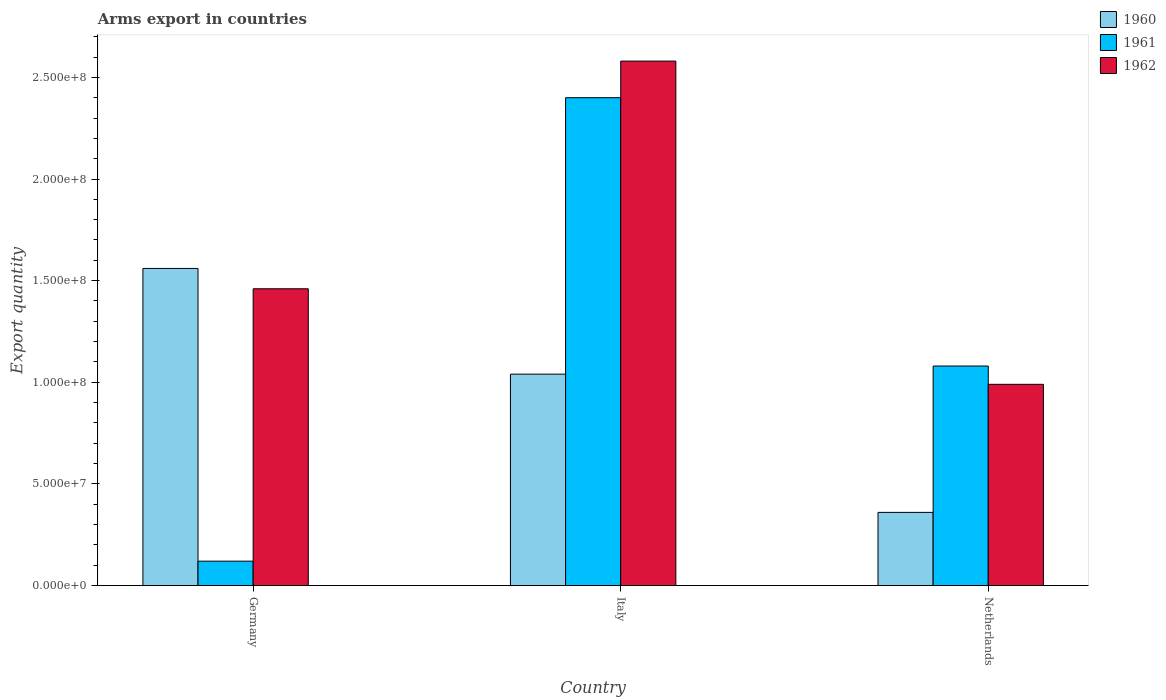How many different coloured bars are there?
Your answer should be compact. 3. Are the number of bars on each tick of the X-axis equal?
Your answer should be very brief. Yes. How many bars are there on the 1st tick from the left?
Provide a short and direct response. 3. What is the label of the 1st group of bars from the left?
Make the answer very short. Germany. In how many cases, is the number of bars for a given country not equal to the number of legend labels?
Ensure brevity in your answer.  0. What is the total arms export in 1961 in Germany?
Give a very brief answer. 1.20e+07. Across all countries, what is the maximum total arms export in 1962?
Make the answer very short. 2.58e+08. Across all countries, what is the minimum total arms export in 1961?
Offer a very short reply. 1.20e+07. In which country was the total arms export in 1962 maximum?
Offer a terse response. Italy. What is the total total arms export in 1961 in the graph?
Provide a succinct answer. 3.60e+08. What is the difference between the total arms export in 1960 in Germany and that in Netherlands?
Ensure brevity in your answer.  1.20e+08. What is the difference between the total arms export in 1961 in Netherlands and the total arms export in 1960 in Germany?
Ensure brevity in your answer.  -4.80e+07. What is the average total arms export in 1962 per country?
Your response must be concise. 1.68e+08. In how many countries, is the total arms export in 1961 greater than 160000000?
Keep it short and to the point. 1. What is the ratio of the total arms export in 1961 in Italy to that in Netherlands?
Your answer should be compact. 2.22. Is the total arms export in 1961 in Germany less than that in Italy?
Make the answer very short. Yes. What is the difference between the highest and the second highest total arms export in 1962?
Offer a very short reply. 1.12e+08. What is the difference between the highest and the lowest total arms export in 1960?
Make the answer very short. 1.20e+08. How many bars are there?
Give a very brief answer. 9. What is the difference between two consecutive major ticks on the Y-axis?
Keep it short and to the point. 5.00e+07. Are the values on the major ticks of Y-axis written in scientific E-notation?
Offer a terse response. Yes. Where does the legend appear in the graph?
Provide a short and direct response. Top right. What is the title of the graph?
Offer a very short reply. Arms export in countries. Does "1993" appear as one of the legend labels in the graph?
Your answer should be compact. No. What is the label or title of the Y-axis?
Provide a short and direct response. Export quantity. What is the Export quantity in 1960 in Germany?
Provide a succinct answer. 1.56e+08. What is the Export quantity in 1962 in Germany?
Give a very brief answer. 1.46e+08. What is the Export quantity in 1960 in Italy?
Keep it short and to the point. 1.04e+08. What is the Export quantity in 1961 in Italy?
Provide a short and direct response. 2.40e+08. What is the Export quantity in 1962 in Italy?
Offer a very short reply. 2.58e+08. What is the Export quantity of 1960 in Netherlands?
Keep it short and to the point. 3.60e+07. What is the Export quantity of 1961 in Netherlands?
Offer a very short reply. 1.08e+08. What is the Export quantity of 1962 in Netherlands?
Provide a short and direct response. 9.90e+07. Across all countries, what is the maximum Export quantity of 1960?
Make the answer very short. 1.56e+08. Across all countries, what is the maximum Export quantity of 1961?
Provide a succinct answer. 2.40e+08. Across all countries, what is the maximum Export quantity of 1962?
Your response must be concise. 2.58e+08. Across all countries, what is the minimum Export quantity of 1960?
Provide a succinct answer. 3.60e+07. Across all countries, what is the minimum Export quantity of 1962?
Offer a terse response. 9.90e+07. What is the total Export quantity of 1960 in the graph?
Give a very brief answer. 2.96e+08. What is the total Export quantity of 1961 in the graph?
Your response must be concise. 3.60e+08. What is the total Export quantity in 1962 in the graph?
Offer a terse response. 5.03e+08. What is the difference between the Export quantity of 1960 in Germany and that in Italy?
Provide a succinct answer. 5.20e+07. What is the difference between the Export quantity in 1961 in Germany and that in Italy?
Give a very brief answer. -2.28e+08. What is the difference between the Export quantity of 1962 in Germany and that in Italy?
Keep it short and to the point. -1.12e+08. What is the difference between the Export quantity of 1960 in Germany and that in Netherlands?
Keep it short and to the point. 1.20e+08. What is the difference between the Export quantity of 1961 in Germany and that in Netherlands?
Make the answer very short. -9.60e+07. What is the difference between the Export quantity of 1962 in Germany and that in Netherlands?
Your response must be concise. 4.70e+07. What is the difference between the Export quantity in 1960 in Italy and that in Netherlands?
Offer a very short reply. 6.80e+07. What is the difference between the Export quantity in 1961 in Italy and that in Netherlands?
Keep it short and to the point. 1.32e+08. What is the difference between the Export quantity in 1962 in Italy and that in Netherlands?
Offer a very short reply. 1.59e+08. What is the difference between the Export quantity in 1960 in Germany and the Export quantity in 1961 in Italy?
Your answer should be compact. -8.40e+07. What is the difference between the Export quantity in 1960 in Germany and the Export quantity in 1962 in Italy?
Give a very brief answer. -1.02e+08. What is the difference between the Export quantity of 1961 in Germany and the Export quantity of 1962 in Italy?
Ensure brevity in your answer.  -2.46e+08. What is the difference between the Export quantity in 1960 in Germany and the Export quantity in 1961 in Netherlands?
Keep it short and to the point. 4.80e+07. What is the difference between the Export quantity in 1960 in Germany and the Export quantity in 1962 in Netherlands?
Provide a short and direct response. 5.70e+07. What is the difference between the Export quantity of 1961 in Germany and the Export quantity of 1962 in Netherlands?
Provide a succinct answer. -8.70e+07. What is the difference between the Export quantity of 1960 in Italy and the Export quantity of 1961 in Netherlands?
Give a very brief answer. -4.00e+06. What is the difference between the Export quantity in 1960 in Italy and the Export quantity in 1962 in Netherlands?
Your response must be concise. 5.00e+06. What is the difference between the Export quantity in 1961 in Italy and the Export quantity in 1962 in Netherlands?
Give a very brief answer. 1.41e+08. What is the average Export quantity in 1960 per country?
Make the answer very short. 9.87e+07. What is the average Export quantity of 1961 per country?
Offer a very short reply. 1.20e+08. What is the average Export quantity in 1962 per country?
Give a very brief answer. 1.68e+08. What is the difference between the Export quantity of 1960 and Export quantity of 1961 in Germany?
Keep it short and to the point. 1.44e+08. What is the difference between the Export quantity in 1961 and Export quantity in 1962 in Germany?
Give a very brief answer. -1.34e+08. What is the difference between the Export quantity of 1960 and Export quantity of 1961 in Italy?
Offer a terse response. -1.36e+08. What is the difference between the Export quantity in 1960 and Export quantity in 1962 in Italy?
Offer a terse response. -1.54e+08. What is the difference between the Export quantity of 1961 and Export quantity of 1962 in Italy?
Your response must be concise. -1.80e+07. What is the difference between the Export quantity of 1960 and Export quantity of 1961 in Netherlands?
Provide a short and direct response. -7.20e+07. What is the difference between the Export quantity in 1960 and Export quantity in 1962 in Netherlands?
Offer a very short reply. -6.30e+07. What is the difference between the Export quantity of 1961 and Export quantity of 1962 in Netherlands?
Provide a succinct answer. 9.00e+06. What is the ratio of the Export quantity of 1960 in Germany to that in Italy?
Provide a succinct answer. 1.5. What is the ratio of the Export quantity of 1961 in Germany to that in Italy?
Keep it short and to the point. 0.05. What is the ratio of the Export quantity of 1962 in Germany to that in Italy?
Keep it short and to the point. 0.57. What is the ratio of the Export quantity in 1960 in Germany to that in Netherlands?
Your answer should be compact. 4.33. What is the ratio of the Export quantity of 1962 in Germany to that in Netherlands?
Offer a terse response. 1.47. What is the ratio of the Export quantity in 1960 in Italy to that in Netherlands?
Keep it short and to the point. 2.89. What is the ratio of the Export quantity in 1961 in Italy to that in Netherlands?
Your answer should be very brief. 2.22. What is the ratio of the Export quantity of 1962 in Italy to that in Netherlands?
Provide a short and direct response. 2.61. What is the difference between the highest and the second highest Export quantity in 1960?
Your answer should be very brief. 5.20e+07. What is the difference between the highest and the second highest Export quantity in 1961?
Provide a short and direct response. 1.32e+08. What is the difference between the highest and the second highest Export quantity of 1962?
Give a very brief answer. 1.12e+08. What is the difference between the highest and the lowest Export quantity in 1960?
Give a very brief answer. 1.20e+08. What is the difference between the highest and the lowest Export quantity of 1961?
Your answer should be very brief. 2.28e+08. What is the difference between the highest and the lowest Export quantity of 1962?
Offer a terse response. 1.59e+08. 